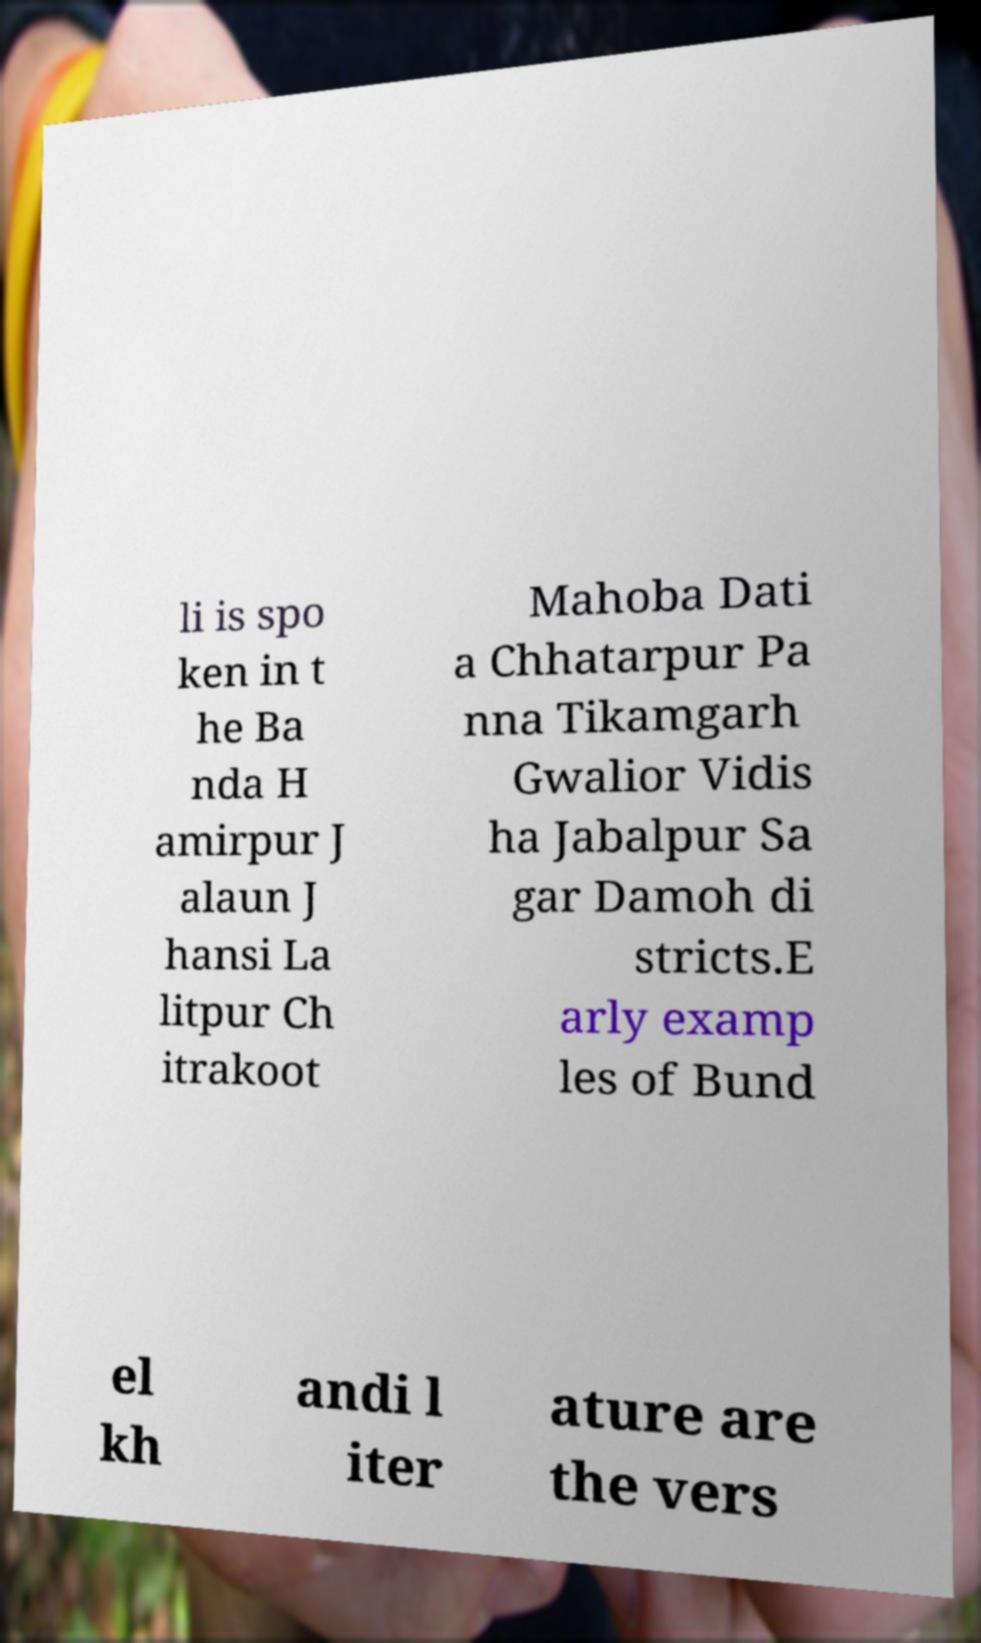There's text embedded in this image that I need extracted. Can you transcribe it verbatim? li is spo ken in t he Ba nda H amirpur J alaun J hansi La litpur Ch itrakoot Mahoba Dati a Chhatarpur Pa nna Tikamgarh Gwalior Vidis ha Jabalpur Sa gar Damoh di stricts.E arly examp les of Bund el kh andi l iter ature are the vers 